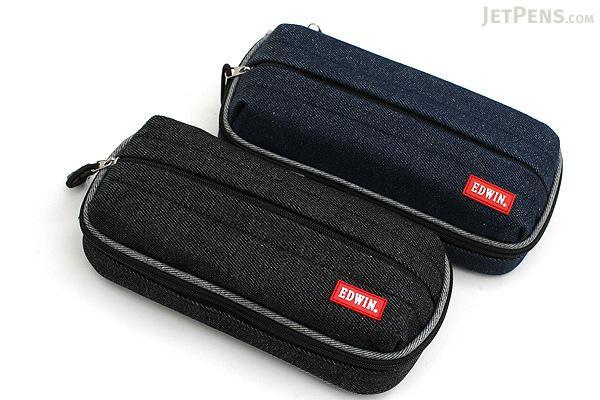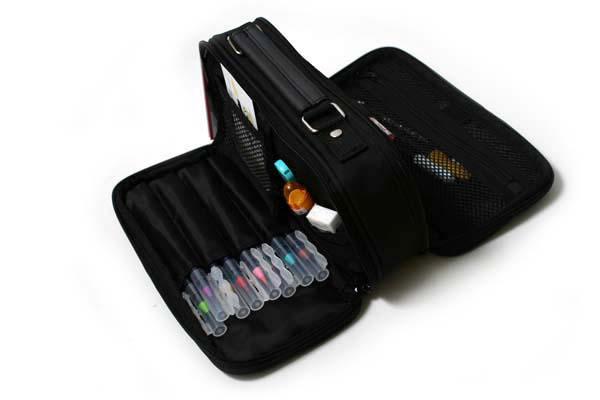The first image is the image on the left, the second image is the image on the right. Assess this claim about the two images: "At least two of the cases are open.". Correct or not? Answer yes or no. No. 